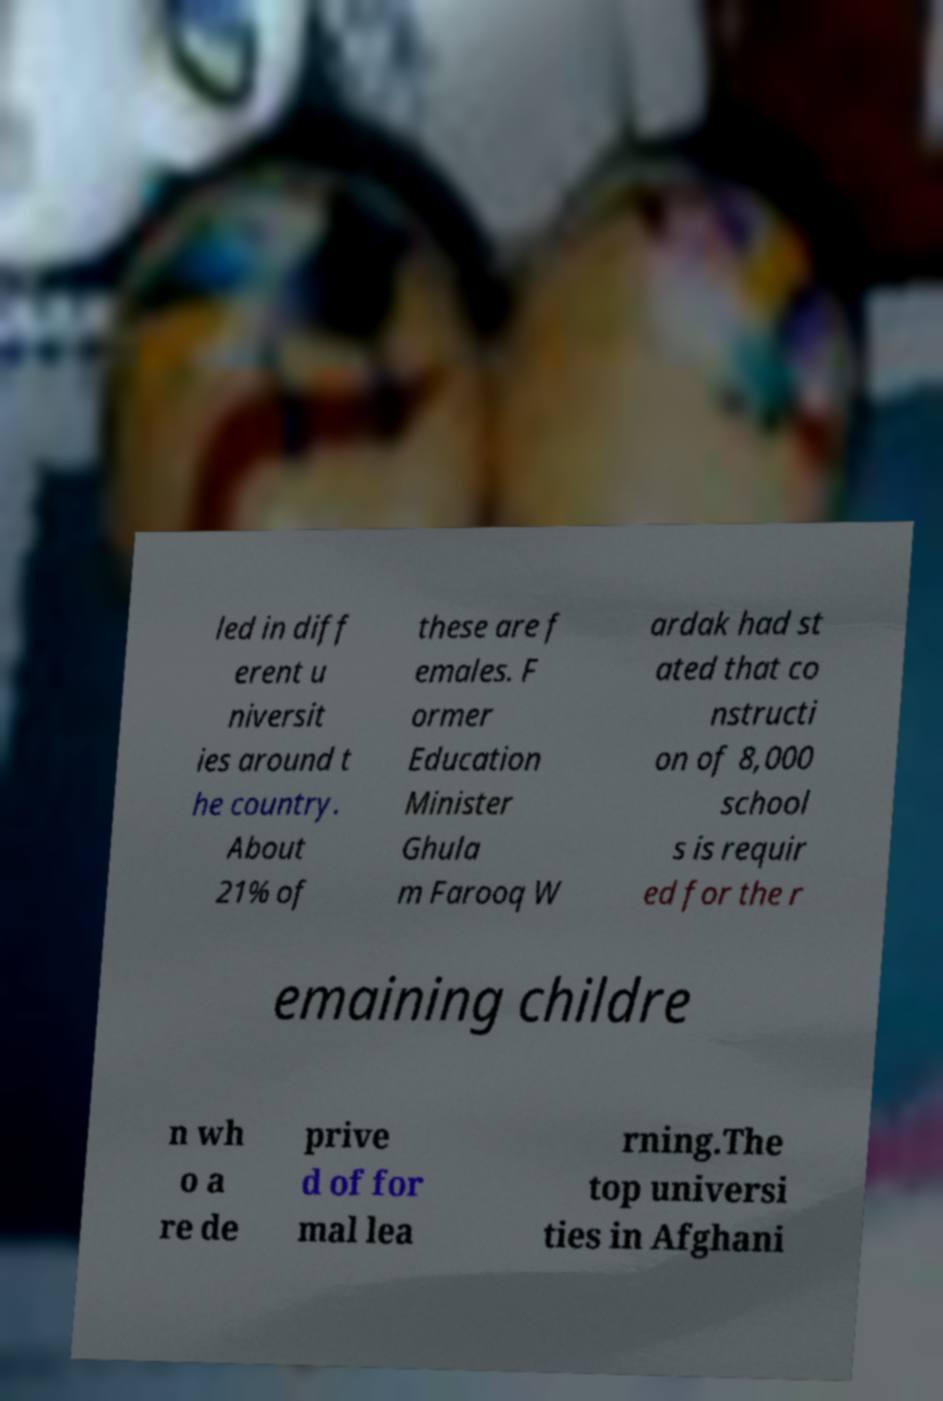Please identify and transcribe the text found in this image. led in diff erent u niversit ies around t he country. About 21% of these are f emales. F ormer Education Minister Ghula m Farooq W ardak had st ated that co nstructi on of 8,000 school s is requir ed for the r emaining childre n wh o a re de prive d of for mal lea rning.The top universi ties in Afghani 